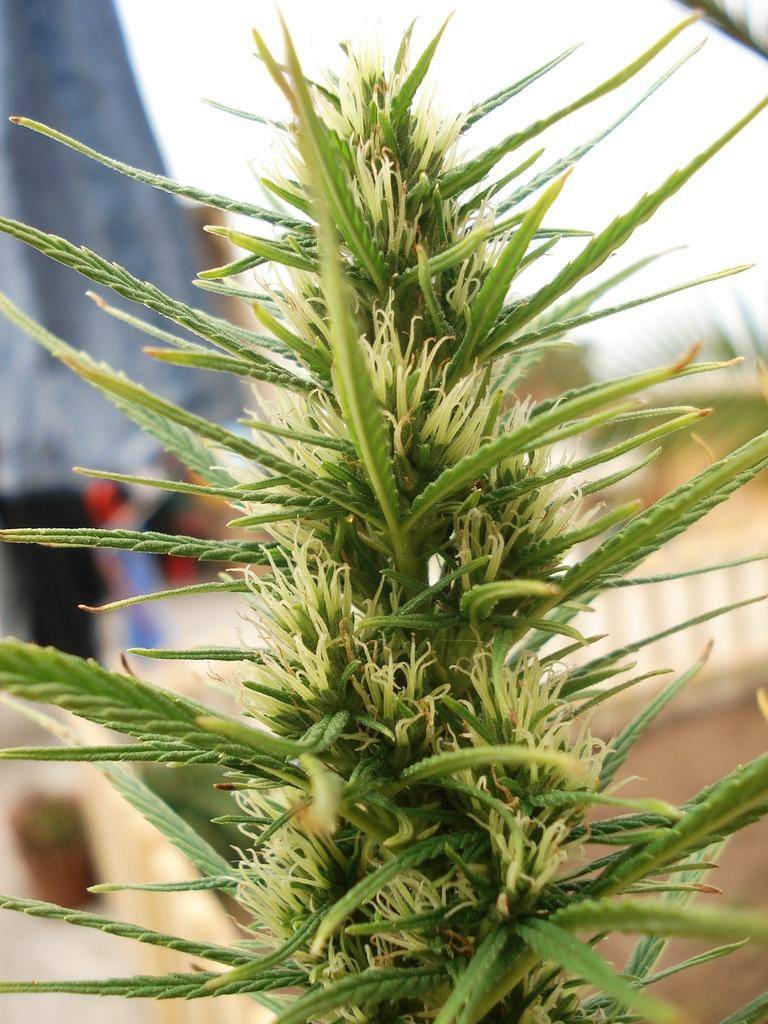What is present in the image? There is a plant in the image. Can you describe the background of the image? The background of the image is blurred. What type of theory is being discussed in the image? There is no discussion or mention of any theory in the image; it features a plant and a blurred background. How many apples are visible in the image? There are no apples present in the image. 